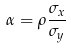Convert formula to latex. <formula><loc_0><loc_0><loc_500><loc_500>\alpha = \rho \frac { \sigma _ { x } } { \sigma _ { y } }</formula> 